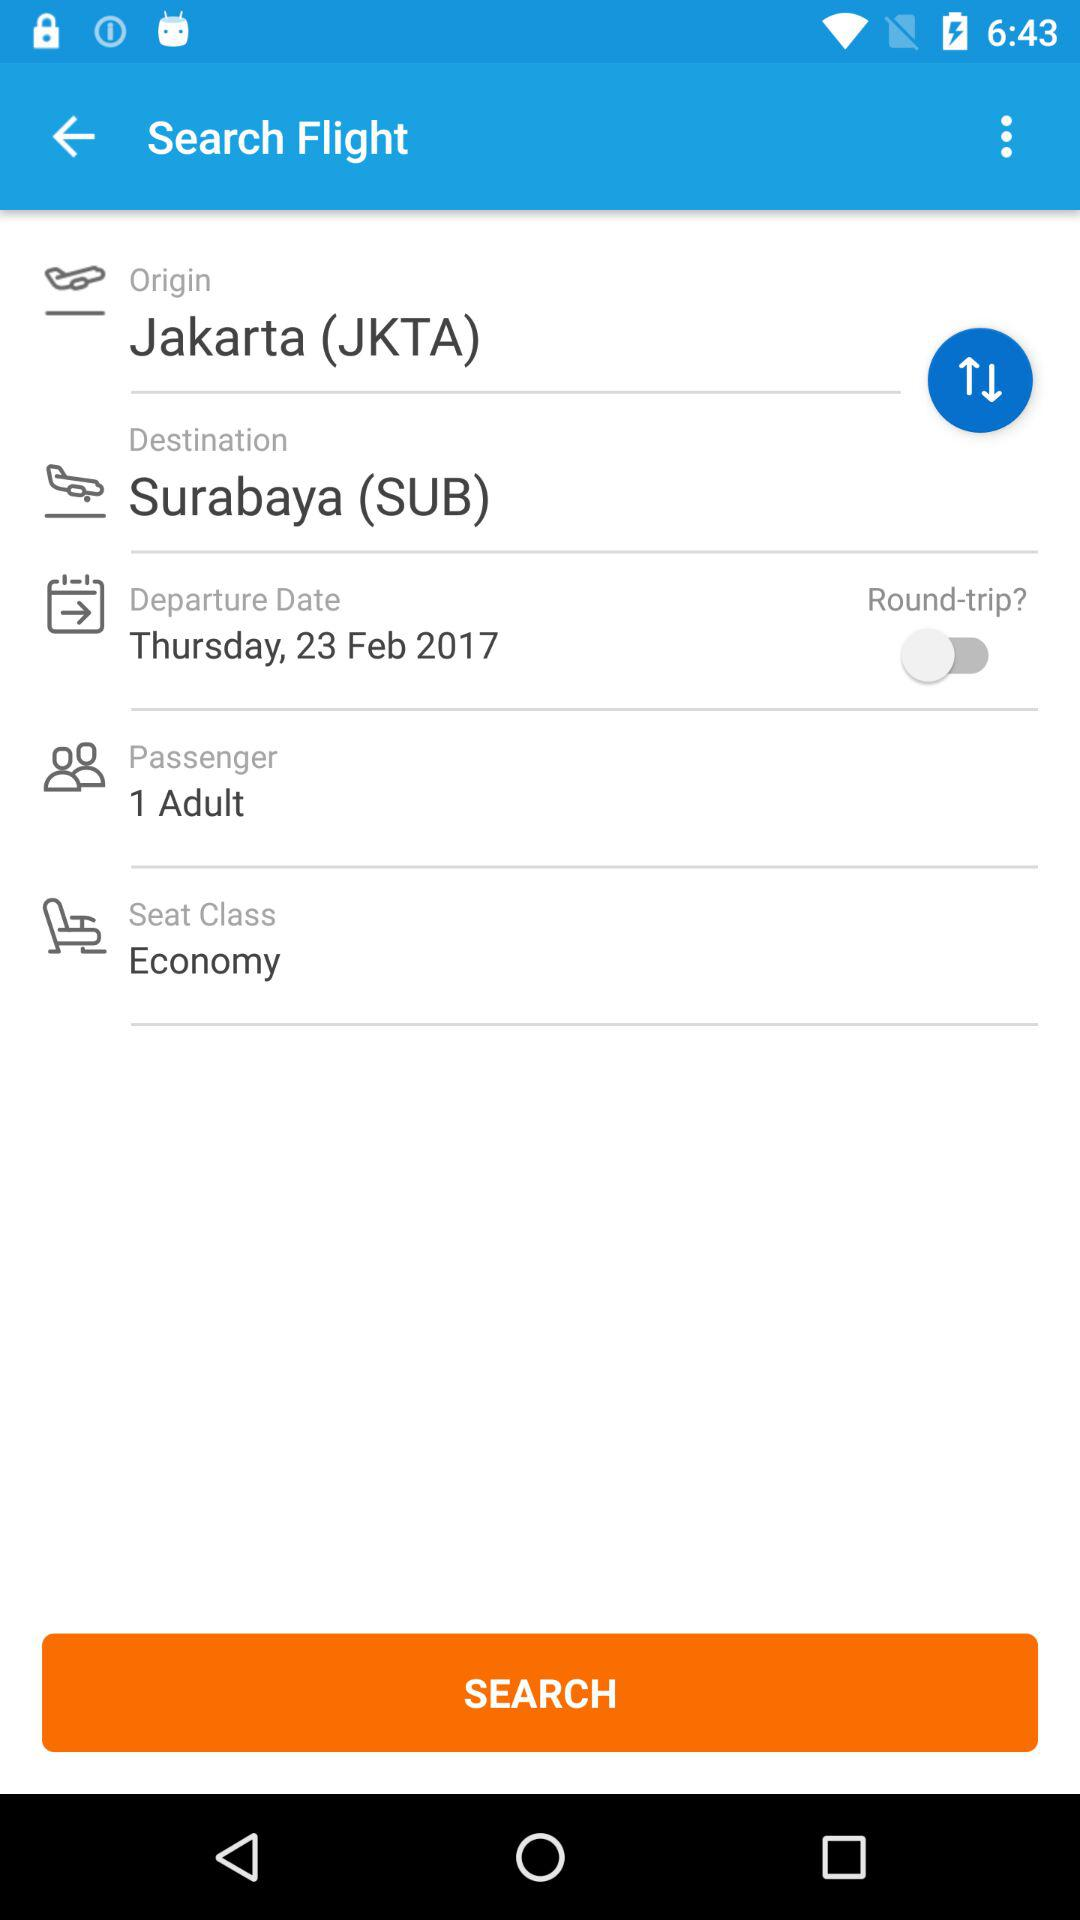When did the flight depart? The flight departed on Thursday, February 23, 2017. 